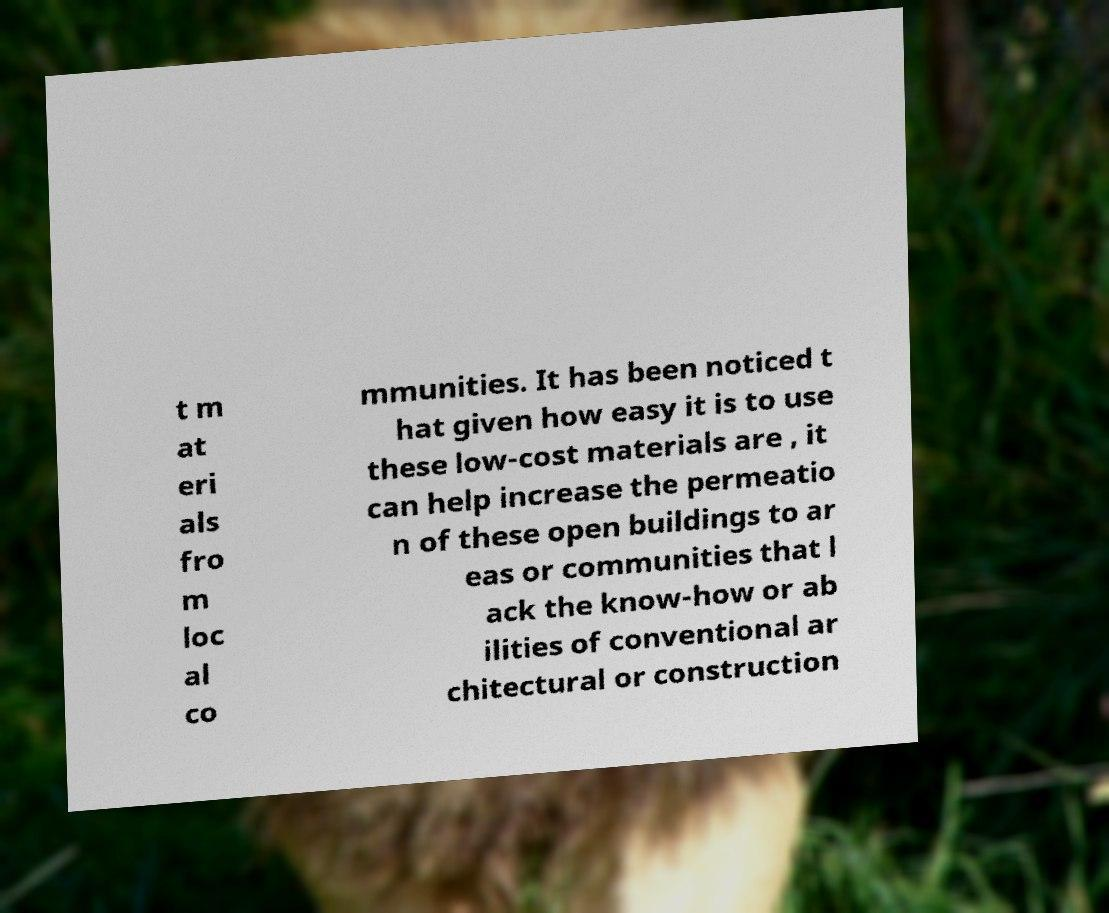Can you accurately transcribe the text from the provided image for me? t m at eri als fro m loc al co mmunities. It has been noticed t hat given how easy it is to use these low-cost materials are , it can help increase the permeatio n of these open buildings to ar eas or communities that l ack the know-how or ab ilities of conventional ar chitectural or construction 